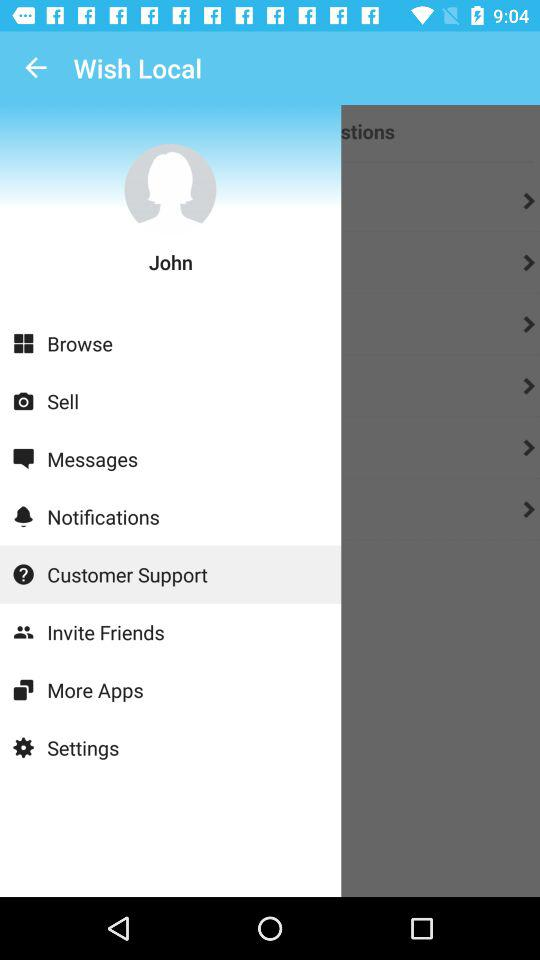Which item has been selected? The selected item is "Customer Support". 